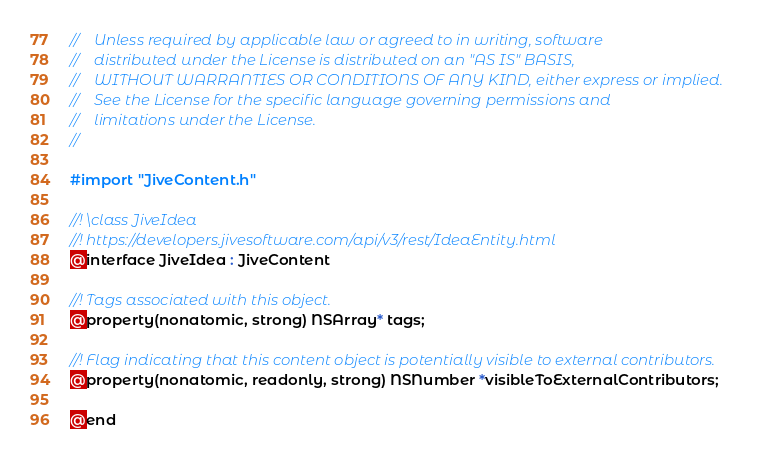Convert code to text. <code><loc_0><loc_0><loc_500><loc_500><_C_>//    Unless required by applicable law or agreed to in writing, software
//    distributed under the License is distributed on an "AS IS" BASIS,
//    WITHOUT WARRANTIES OR CONDITIONS OF ANY KIND, either express or implied.
//    See the License for the specific language governing permissions and
//    limitations under the License.
//

#import "JiveContent.h"

//! \class JiveIdea
//! https://developers.jivesoftware.com/api/v3/rest/IdeaEntity.html
@interface JiveIdea : JiveContent

//! Tags associated with this object.
@property(nonatomic, strong) NSArray* tags;

//! Flag indicating that this content object is potentially visible to external contributors.
@property(nonatomic, readonly, strong) NSNumber *visibleToExternalContributors;

@end
</code> 